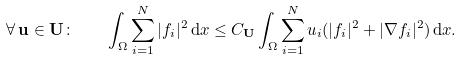Convert formula to latex. <formula><loc_0><loc_0><loc_500><loc_500>\forall \, \mathbf u \in \mathbf U \colon \quad \int _ { \Omega } \sum _ { i = 1 } ^ { N } | f _ { i } | ^ { 2 } \, \mathrm d x \leq C _ { \mathbf U } \int _ { \Omega } \sum _ { i = 1 } ^ { N } u _ { i } ( | f _ { i } | ^ { 2 } + | \nabla f _ { i } | ^ { 2 } ) \, \mathrm d x .</formula> 